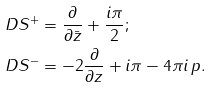<formula> <loc_0><loc_0><loc_500><loc_500>\ D S ^ { + } & = \frac { \partial } { \partial \bar { z } } + \frac { i \pi } { 2 } ; \\ \ D S ^ { - } & = - 2 \frac { \partial } { \partial z } + i \pi - 4 \pi i \, p .</formula> 